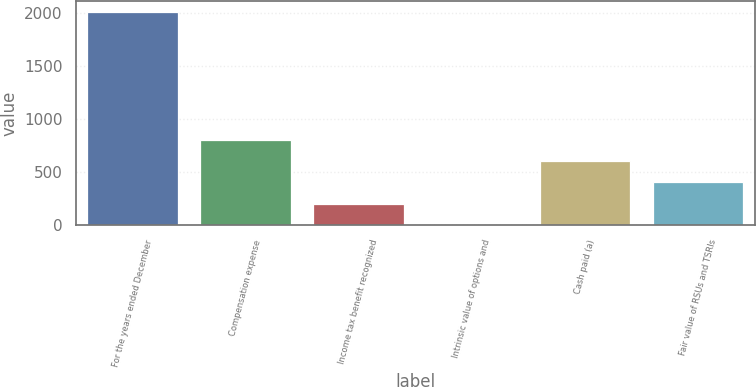Convert chart to OTSL. <chart><loc_0><loc_0><loc_500><loc_500><bar_chart><fcel>For the years ended December<fcel>Compensation expense<fcel>Income tax benefit recognized<fcel>Intrinsic value of options and<fcel>Cash paid (a)<fcel>Fair value of RSUs and TSRIs<nl><fcel>2014<fcel>808.6<fcel>205.9<fcel>5<fcel>607.7<fcel>406.8<nl></chart> 